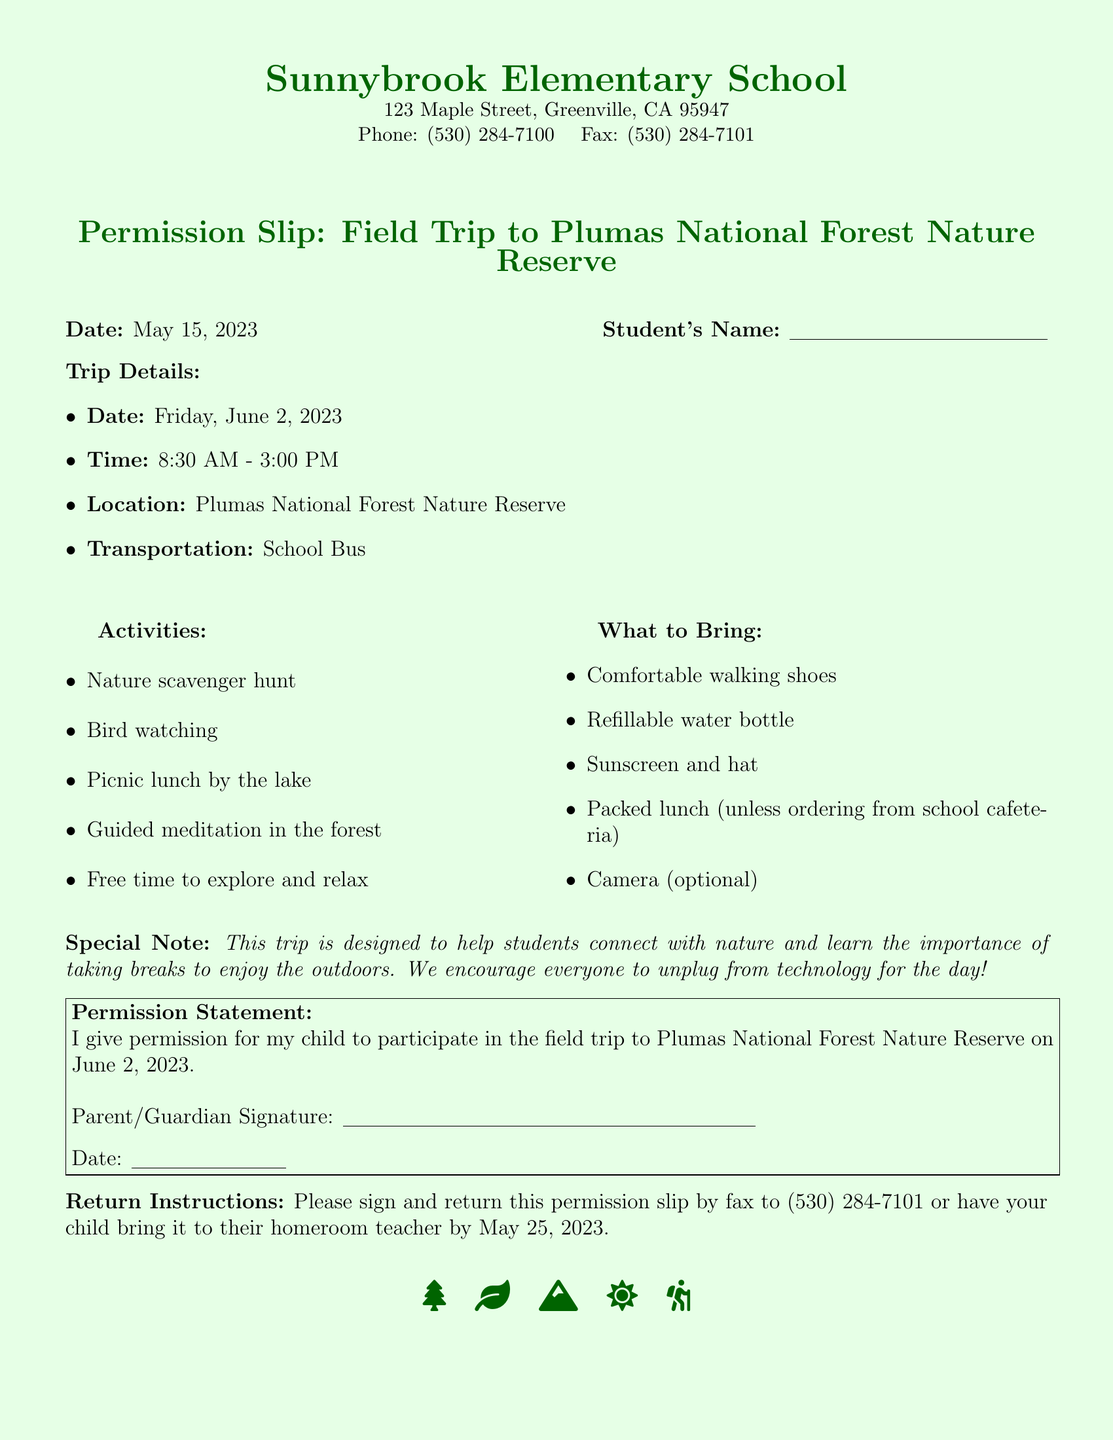What is the date of the field trip? The field trip is scheduled for June 2, 2023.
Answer: June 2, 2023 What is the starting time of the trip? The trip begins at 8:30 AM.
Answer: 8:30 AM What is one activity planned for the trip? One of the activities is a nature scavenger hunt.
Answer: Nature scavenger hunt What should students bring for the trip? Students are advised to bring a refillable water bottle.
Answer: Refillable water bottle What is the transportation method for the trip? The students will be transported by school bus.
Answer: School Bus Why is this trip significant for students? The trip is designed to help students connect with nature and take breaks to enjoy the outdoors.
Answer: Connect with nature What is the return deadline for the permission slip? The permission slip must be returned by May 25, 2023.
Answer: May 25, 2023 What is the location of the field trip? The field trip will take place at Plumas National Forest Nature Reserve.
Answer: Plumas National Forest Nature Reserve How can parents submit the permission slip? Parents can fax the permission slip to the school or have their child bring it to homeroom.
Answer: Fax or homeroom 